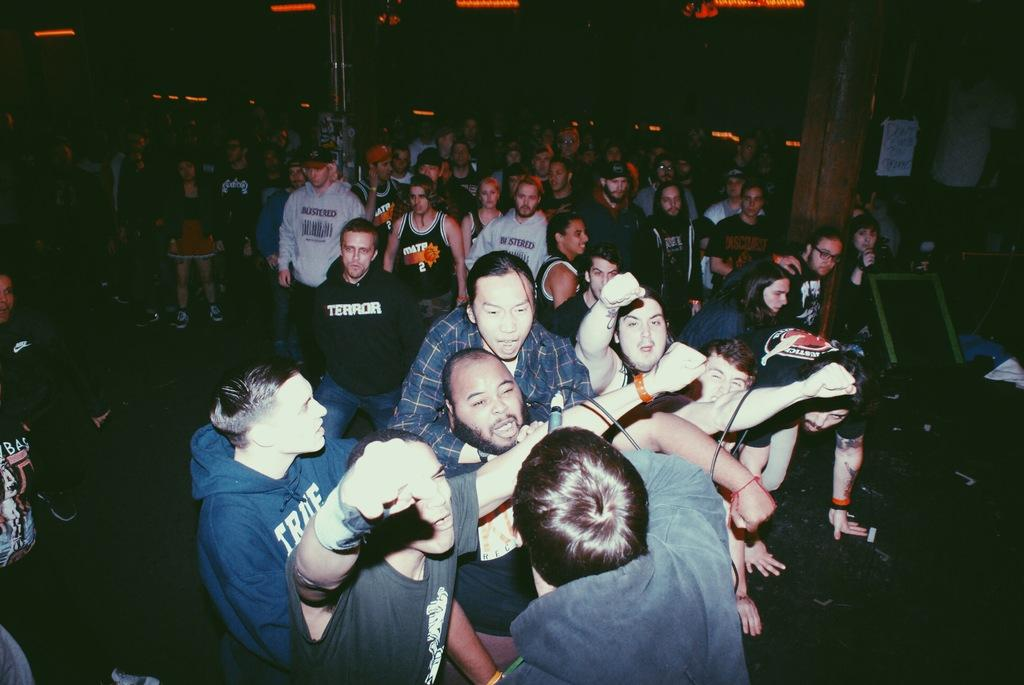Who or what can be seen in the image? There are people in the image. What is the board in the image used for? The board in the image is not described in the facts, so we cannot determine its purpose. What is depicted on the poster in the image? The facts do not mention the content of the poster, so we cannot describe it. What is the pillar in the image supporting? The facts do not specify what the pillar is supporting, so we cannot determine its purpose. What types of objects are present in the image? The facts mention that there are objects in the image, but they do not describe them. What is the lighting situation in the image? The background of the image is dark, and there are lights visible in the background. What type of grain is being discussed by the people in the image? There is no mention of grain or any discussion in the image, so we cannot answer this question. 